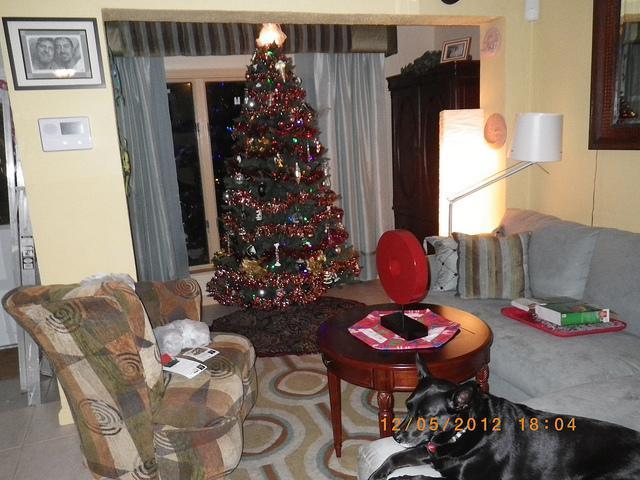How many pillows on the couch?
Give a very brief answer. 2. How many couches are in the photo?
Give a very brief answer. 2. 